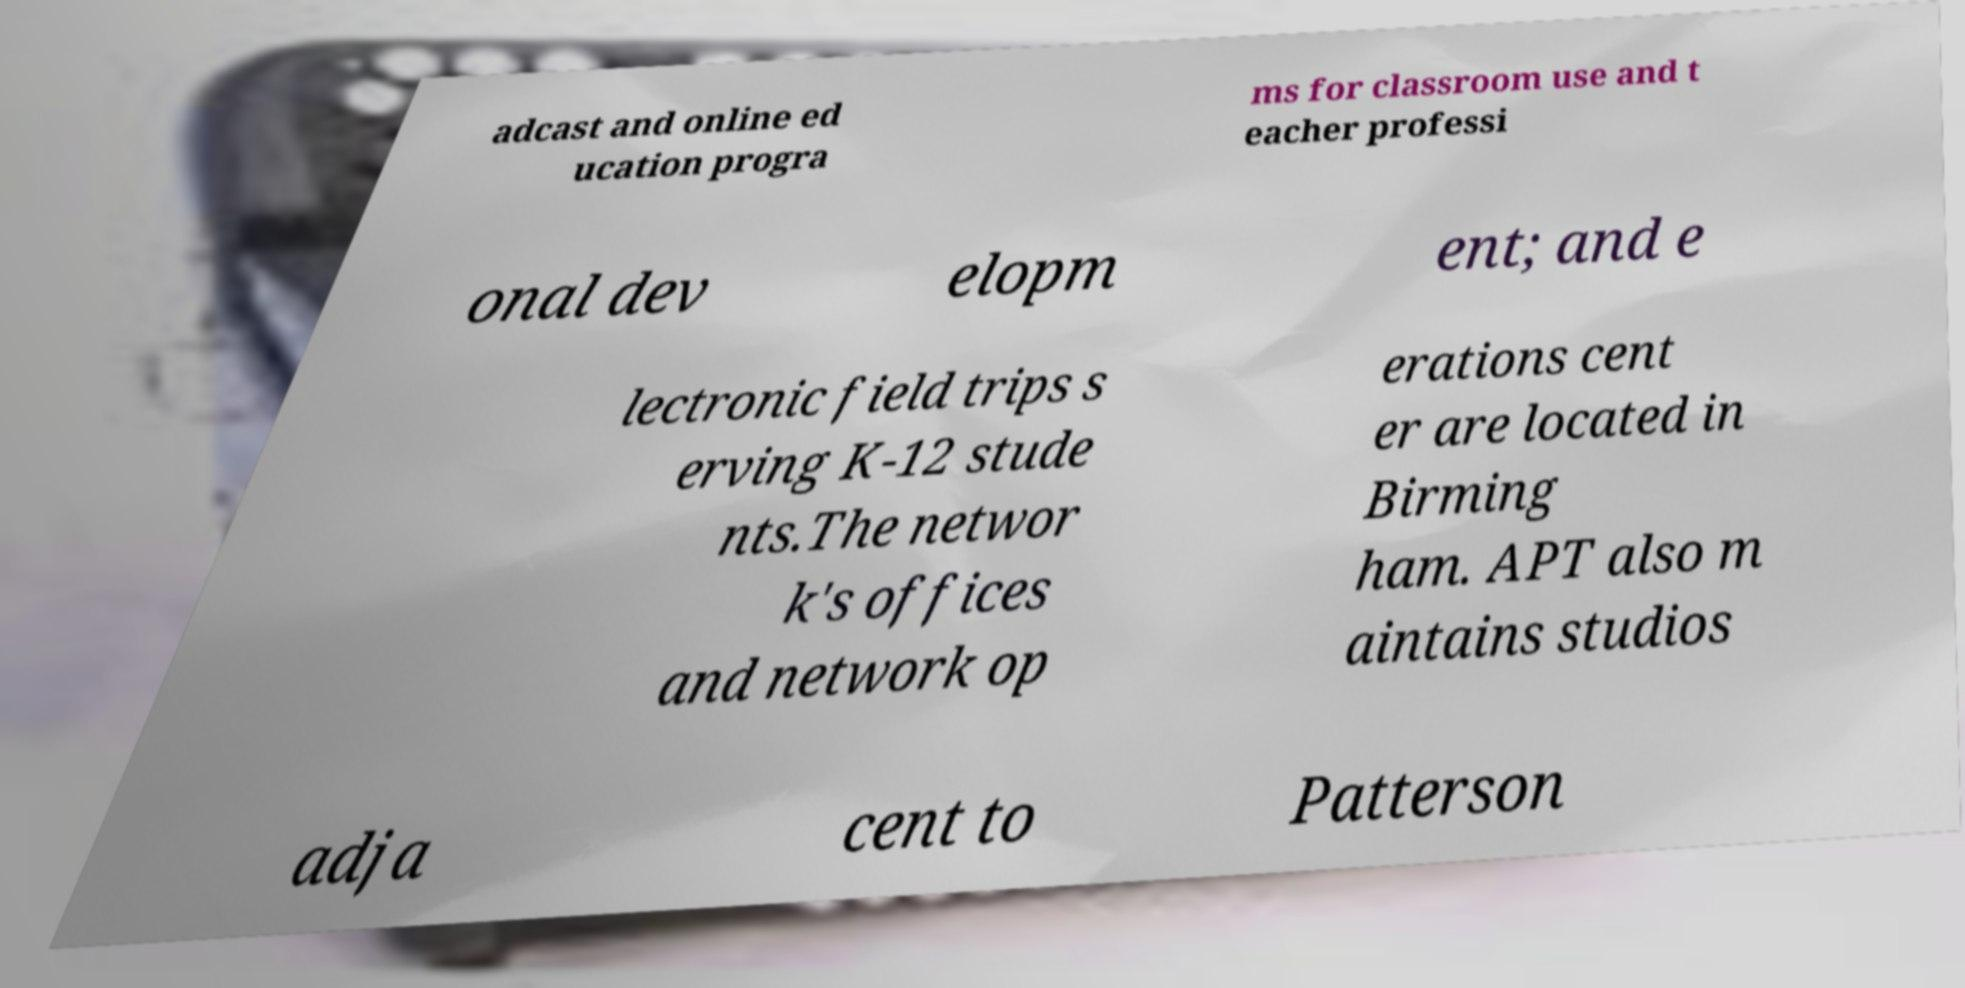Please identify and transcribe the text found in this image. adcast and online ed ucation progra ms for classroom use and t eacher professi onal dev elopm ent; and e lectronic field trips s erving K-12 stude nts.The networ k's offices and network op erations cent er are located in Birming ham. APT also m aintains studios adja cent to Patterson 